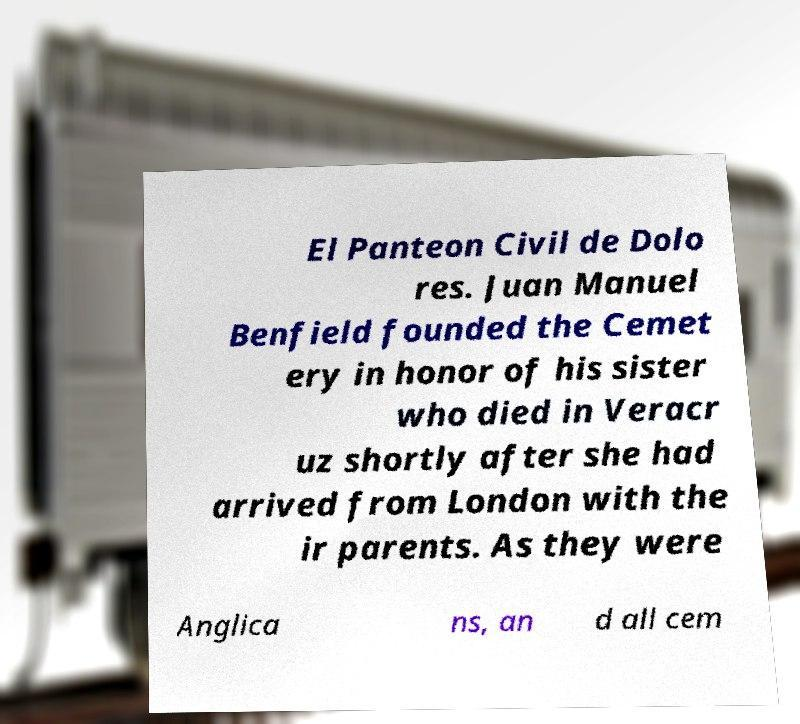For documentation purposes, I need the text within this image transcribed. Could you provide that? El Panteon Civil de Dolo res. Juan Manuel Benfield founded the Cemet ery in honor of his sister who died in Veracr uz shortly after she had arrived from London with the ir parents. As they were Anglica ns, an d all cem 